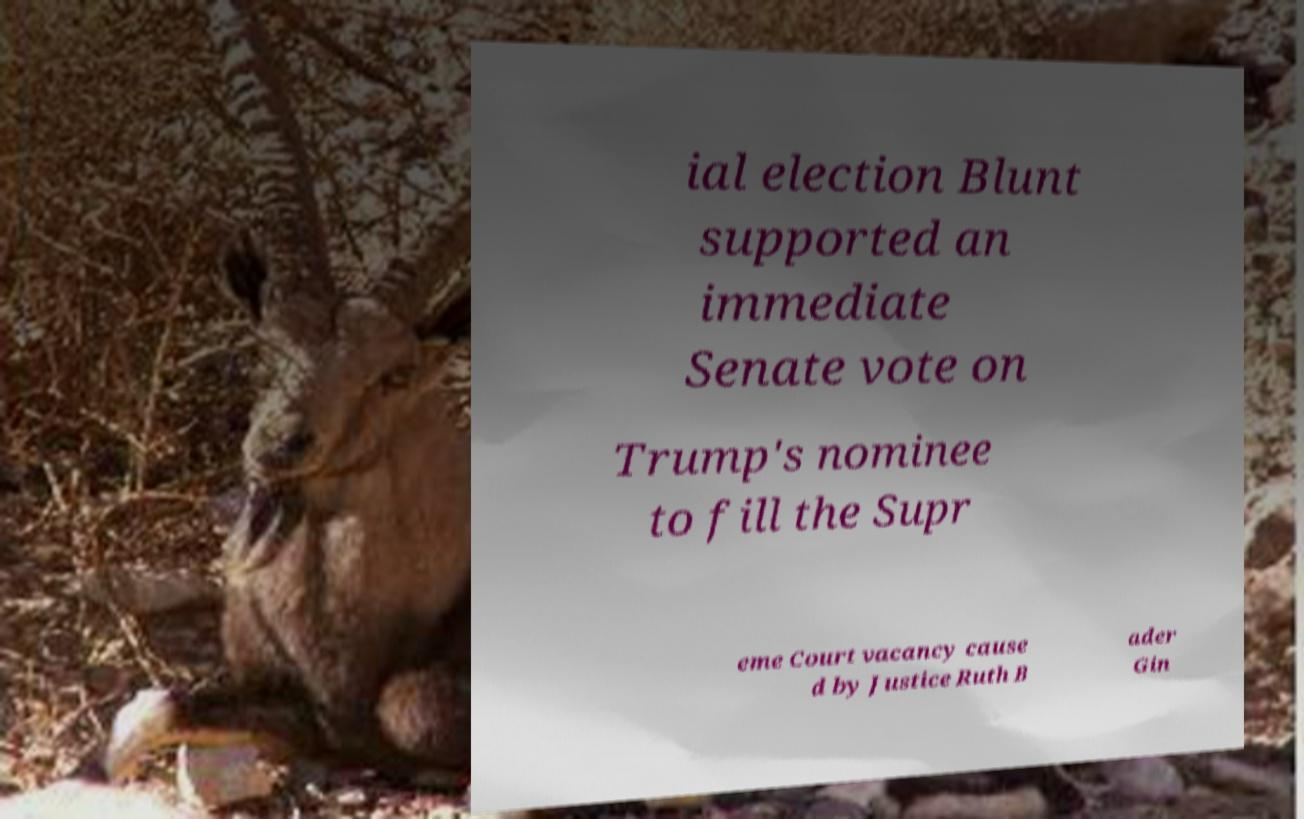Could you extract and type out the text from this image? ial election Blunt supported an immediate Senate vote on Trump's nominee to fill the Supr eme Court vacancy cause d by Justice Ruth B ader Gin 